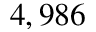<formula> <loc_0><loc_0><loc_500><loc_500>4 , 9 8 6</formula> 